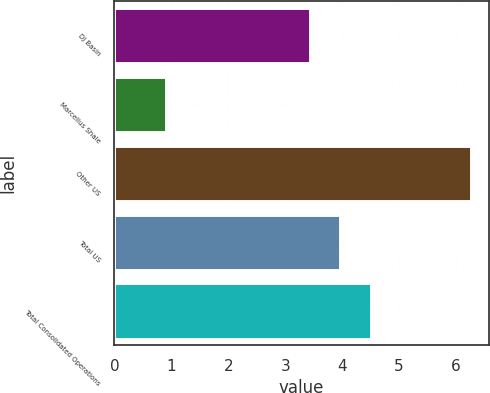Convert chart to OTSL. <chart><loc_0><loc_0><loc_500><loc_500><bar_chart><fcel>DJ Basin<fcel>Marcellus Shale<fcel>Other US<fcel>Total US<fcel>Total Consolidated Operations<nl><fcel>3.43<fcel>0.9<fcel>6.26<fcel>3.97<fcel>4.51<nl></chart> 